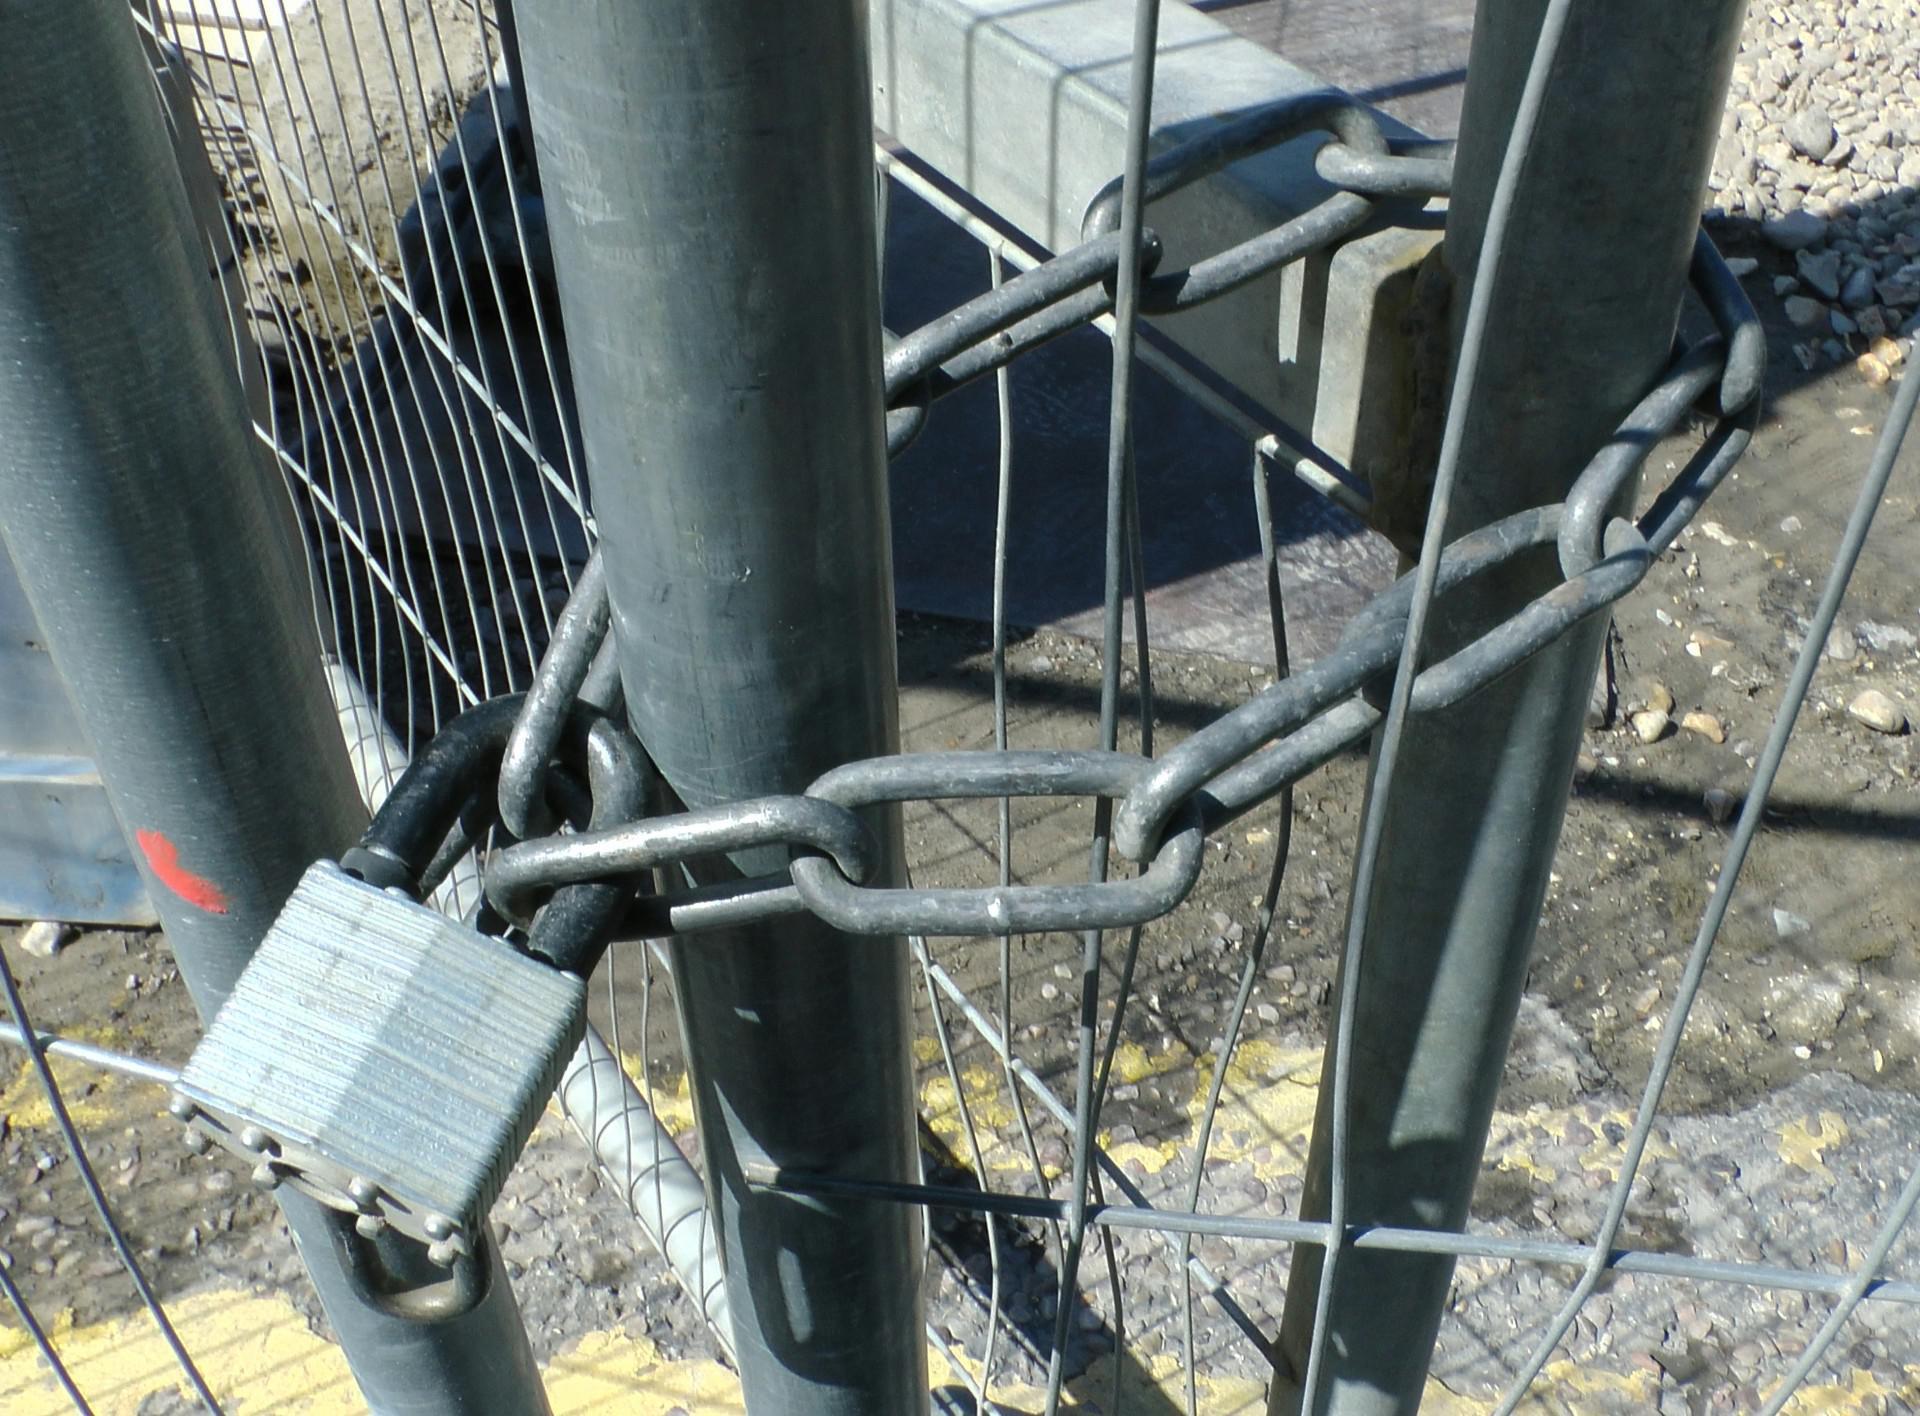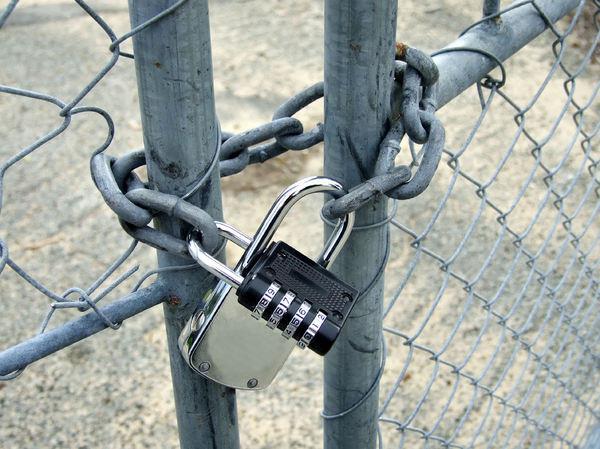The first image is the image on the left, the second image is the image on the right. For the images displayed, is the sentence "In one of the images, the locks are seen placed on something other than a metal fence." factually correct? Answer yes or no. No. The first image is the image on the left, the second image is the image on the right. Analyze the images presented: Is the assertion "At least one image contains no less than six locks." valid? Answer yes or no. No. 